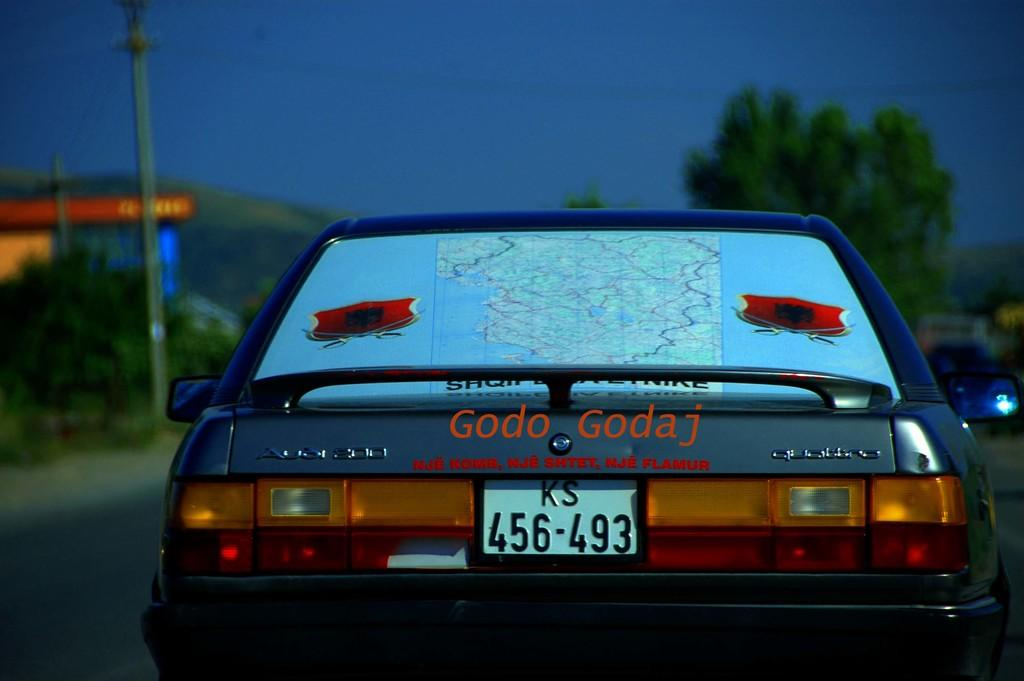What is the main subject in the middle of the image? There is a car in the middle of the image. What is attached to the car? There is a map on the car. What type of natural environment can be seen in the image? Trees are visible in the image. What is visible at the top of the image? The sky is visible at the top of the image. What type of wine is being served in the image? There is no wine present in the image. Can you tell me where the bait is located in the image? There is no bait present in the image. 